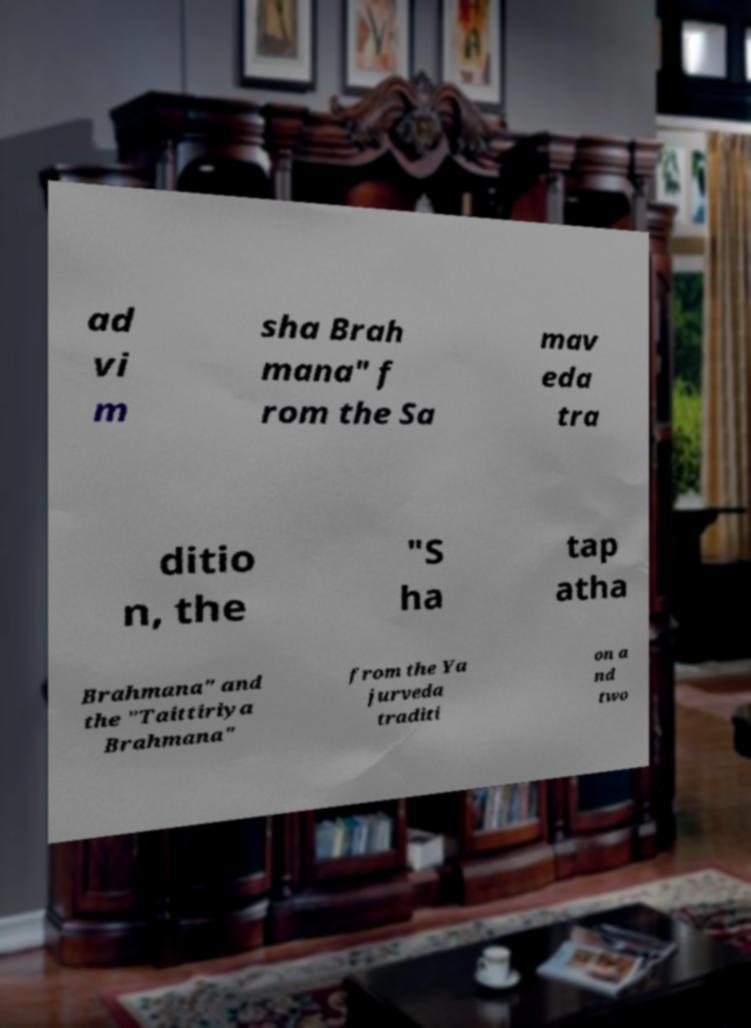Could you extract and type out the text from this image? ad vi m sha Brah mana" f rom the Sa mav eda tra ditio n, the "S ha tap atha Brahmana" and the "Taittiriya Brahmana" from the Ya jurveda traditi on a nd two 